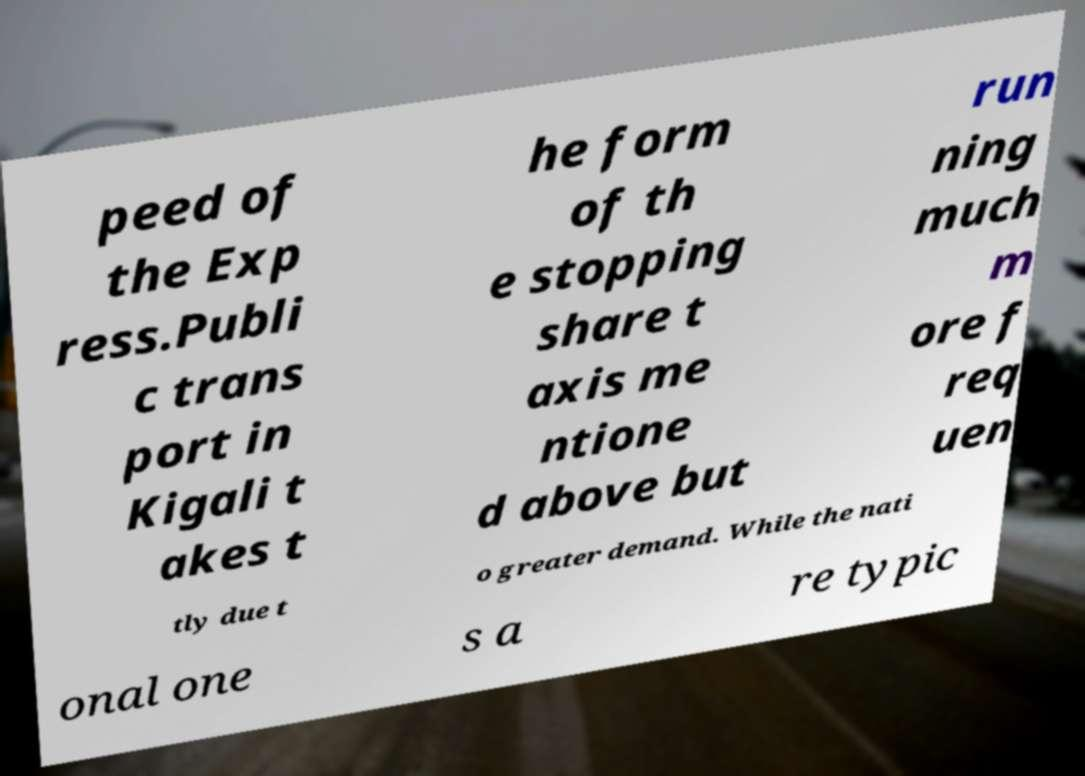Please read and relay the text visible in this image. What does it say? peed of the Exp ress.Publi c trans port in Kigali t akes t he form of th e stopping share t axis me ntione d above but run ning much m ore f req uen tly due t o greater demand. While the nati onal one s a re typic 